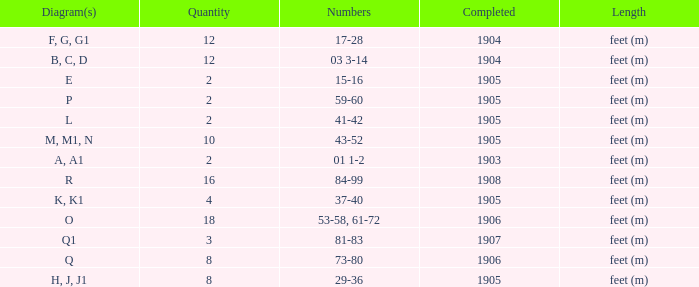What are the numbers for the item completed earlier than 1904? 01 1-2. 